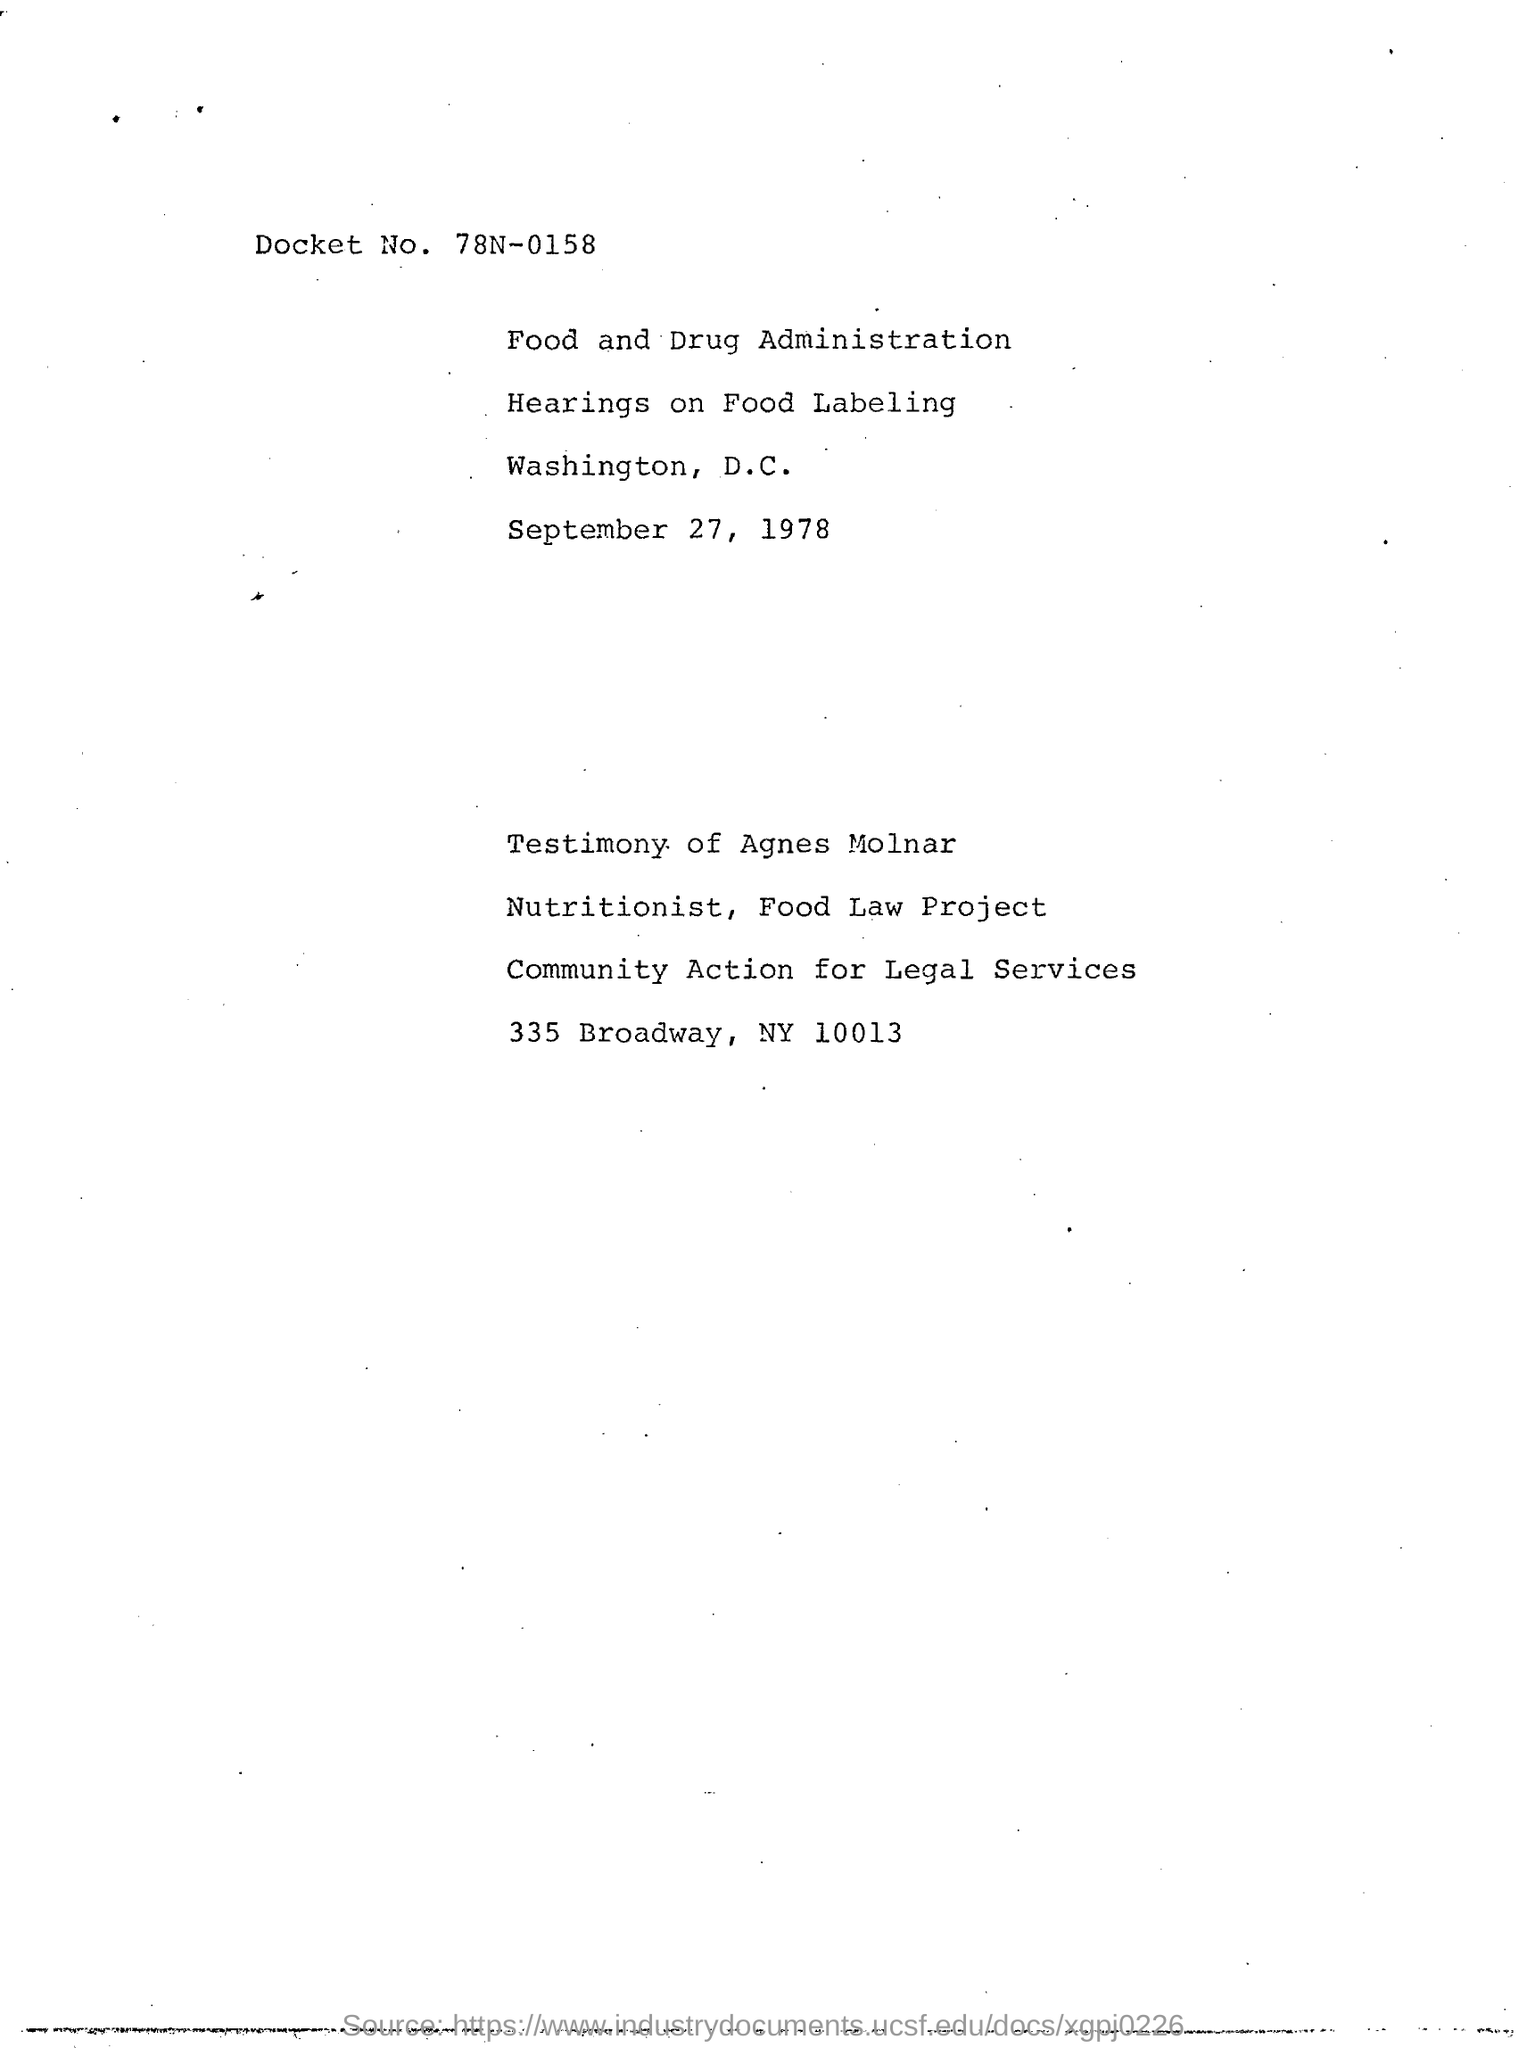Mention a couple of crucial points in this snapshot. What is the docket number for 78N-0158? The date in the document is September 27, 1978. 